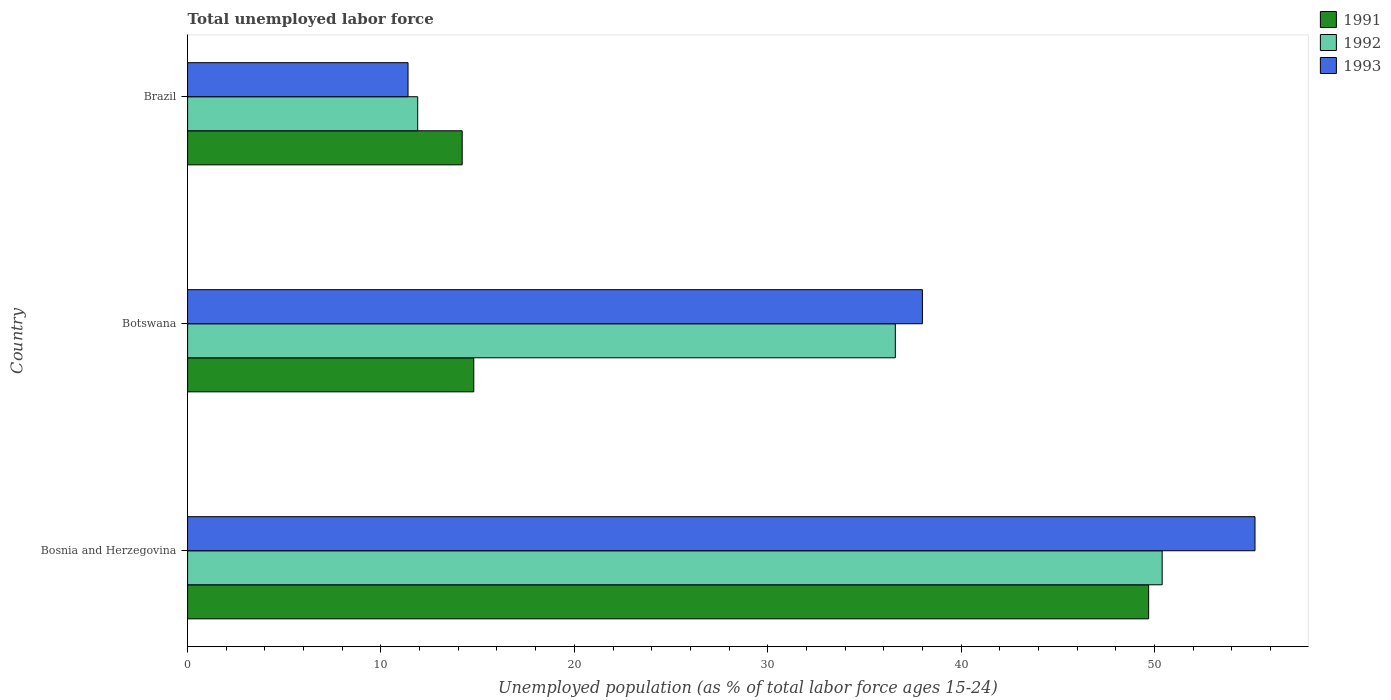How many different coloured bars are there?
Offer a very short reply. 3. How many groups of bars are there?
Keep it short and to the point. 3. Are the number of bars per tick equal to the number of legend labels?
Your answer should be compact. Yes. Are the number of bars on each tick of the Y-axis equal?
Make the answer very short. Yes. How many bars are there on the 1st tick from the top?
Provide a succinct answer. 3. How many bars are there on the 1st tick from the bottom?
Make the answer very short. 3. What is the label of the 3rd group of bars from the top?
Your answer should be compact. Bosnia and Herzegovina. What is the percentage of unemployed population in in 1991 in Brazil?
Your answer should be compact. 14.2. Across all countries, what is the maximum percentage of unemployed population in in 1993?
Offer a very short reply. 55.2. Across all countries, what is the minimum percentage of unemployed population in in 1992?
Make the answer very short. 11.9. In which country was the percentage of unemployed population in in 1992 maximum?
Give a very brief answer. Bosnia and Herzegovina. In which country was the percentage of unemployed population in in 1992 minimum?
Provide a short and direct response. Brazil. What is the total percentage of unemployed population in in 1991 in the graph?
Your response must be concise. 78.7. What is the difference between the percentage of unemployed population in in 1993 in Bosnia and Herzegovina and that in Brazil?
Your answer should be compact. 43.8. What is the difference between the percentage of unemployed population in in 1992 in Bosnia and Herzegovina and the percentage of unemployed population in in 1991 in Brazil?
Your answer should be compact. 36.2. What is the average percentage of unemployed population in in 1992 per country?
Keep it short and to the point. 32.97. What is the difference between the percentage of unemployed population in in 1992 and percentage of unemployed population in in 1991 in Brazil?
Your answer should be compact. -2.3. In how many countries, is the percentage of unemployed population in in 1993 greater than 28 %?
Make the answer very short. 2. What is the ratio of the percentage of unemployed population in in 1991 in Bosnia and Herzegovina to that in Brazil?
Keep it short and to the point. 3.5. Is the percentage of unemployed population in in 1993 in Bosnia and Herzegovina less than that in Brazil?
Provide a succinct answer. No. What is the difference between the highest and the second highest percentage of unemployed population in in 1992?
Provide a short and direct response. 13.8. What is the difference between the highest and the lowest percentage of unemployed population in in 1993?
Keep it short and to the point. 43.8. In how many countries, is the percentage of unemployed population in in 1991 greater than the average percentage of unemployed population in in 1991 taken over all countries?
Your answer should be compact. 1. Is the sum of the percentage of unemployed population in in 1992 in Botswana and Brazil greater than the maximum percentage of unemployed population in in 1991 across all countries?
Your response must be concise. No. What does the 3rd bar from the top in Brazil represents?
Give a very brief answer. 1991. Is it the case that in every country, the sum of the percentage of unemployed population in in 1992 and percentage of unemployed population in in 1991 is greater than the percentage of unemployed population in in 1993?
Ensure brevity in your answer.  Yes. Does the graph contain grids?
Offer a very short reply. No. How many legend labels are there?
Provide a short and direct response. 3. How are the legend labels stacked?
Provide a succinct answer. Vertical. What is the title of the graph?
Provide a short and direct response. Total unemployed labor force. Does "1967" appear as one of the legend labels in the graph?
Keep it short and to the point. No. What is the label or title of the X-axis?
Your answer should be very brief. Unemployed population (as % of total labor force ages 15-24). What is the Unemployed population (as % of total labor force ages 15-24) of 1991 in Bosnia and Herzegovina?
Your response must be concise. 49.7. What is the Unemployed population (as % of total labor force ages 15-24) in 1992 in Bosnia and Herzegovina?
Your response must be concise. 50.4. What is the Unemployed population (as % of total labor force ages 15-24) of 1993 in Bosnia and Herzegovina?
Provide a short and direct response. 55.2. What is the Unemployed population (as % of total labor force ages 15-24) in 1991 in Botswana?
Your response must be concise. 14.8. What is the Unemployed population (as % of total labor force ages 15-24) of 1992 in Botswana?
Your response must be concise. 36.6. What is the Unemployed population (as % of total labor force ages 15-24) of 1993 in Botswana?
Provide a succinct answer. 38. What is the Unemployed population (as % of total labor force ages 15-24) in 1991 in Brazil?
Offer a very short reply. 14.2. What is the Unemployed population (as % of total labor force ages 15-24) of 1992 in Brazil?
Your answer should be compact. 11.9. What is the Unemployed population (as % of total labor force ages 15-24) of 1993 in Brazil?
Provide a succinct answer. 11.4. Across all countries, what is the maximum Unemployed population (as % of total labor force ages 15-24) in 1991?
Provide a succinct answer. 49.7. Across all countries, what is the maximum Unemployed population (as % of total labor force ages 15-24) in 1992?
Offer a very short reply. 50.4. Across all countries, what is the maximum Unemployed population (as % of total labor force ages 15-24) of 1993?
Your answer should be compact. 55.2. Across all countries, what is the minimum Unemployed population (as % of total labor force ages 15-24) in 1991?
Provide a short and direct response. 14.2. Across all countries, what is the minimum Unemployed population (as % of total labor force ages 15-24) in 1992?
Provide a short and direct response. 11.9. Across all countries, what is the minimum Unemployed population (as % of total labor force ages 15-24) in 1993?
Ensure brevity in your answer.  11.4. What is the total Unemployed population (as % of total labor force ages 15-24) of 1991 in the graph?
Your answer should be very brief. 78.7. What is the total Unemployed population (as % of total labor force ages 15-24) of 1992 in the graph?
Offer a very short reply. 98.9. What is the total Unemployed population (as % of total labor force ages 15-24) in 1993 in the graph?
Offer a terse response. 104.6. What is the difference between the Unemployed population (as % of total labor force ages 15-24) of 1991 in Bosnia and Herzegovina and that in Botswana?
Your answer should be compact. 34.9. What is the difference between the Unemployed population (as % of total labor force ages 15-24) of 1992 in Bosnia and Herzegovina and that in Botswana?
Ensure brevity in your answer.  13.8. What is the difference between the Unemployed population (as % of total labor force ages 15-24) in 1993 in Bosnia and Herzegovina and that in Botswana?
Provide a succinct answer. 17.2. What is the difference between the Unemployed population (as % of total labor force ages 15-24) in 1991 in Bosnia and Herzegovina and that in Brazil?
Give a very brief answer. 35.5. What is the difference between the Unemployed population (as % of total labor force ages 15-24) of 1992 in Bosnia and Herzegovina and that in Brazil?
Ensure brevity in your answer.  38.5. What is the difference between the Unemployed population (as % of total labor force ages 15-24) of 1993 in Bosnia and Herzegovina and that in Brazil?
Your answer should be very brief. 43.8. What is the difference between the Unemployed population (as % of total labor force ages 15-24) in 1992 in Botswana and that in Brazil?
Keep it short and to the point. 24.7. What is the difference between the Unemployed population (as % of total labor force ages 15-24) of 1993 in Botswana and that in Brazil?
Provide a succinct answer. 26.6. What is the difference between the Unemployed population (as % of total labor force ages 15-24) of 1991 in Bosnia and Herzegovina and the Unemployed population (as % of total labor force ages 15-24) of 1992 in Botswana?
Ensure brevity in your answer.  13.1. What is the difference between the Unemployed population (as % of total labor force ages 15-24) in 1991 in Bosnia and Herzegovina and the Unemployed population (as % of total labor force ages 15-24) in 1993 in Botswana?
Offer a very short reply. 11.7. What is the difference between the Unemployed population (as % of total labor force ages 15-24) of 1991 in Bosnia and Herzegovina and the Unemployed population (as % of total labor force ages 15-24) of 1992 in Brazil?
Your answer should be very brief. 37.8. What is the difference between the Unemployed population (as % of total labor force ages 15-24) of 1991 in Bosnia and Herzegovina and the Unemployed population (as % of total labor force ages 15-24) of 1993 in Brazil?
Provide a short and direct response. 38.3. What is the difference between the Unemployed population (as % of total labor force ages 15-24) in 1991 in Botswana and the Unemployed population (as % of total labor force ages 15-24) in 1992 in Brazil?
Your response must be concise. 2.9. What is the difference between the Unemployed population (as % of total labor force ages 15-24) in 1991 in Botswana and the Unemployed population (as % of total labor force ages 15-24) in 1993 in Brazil?
Your response must be concise. 3.4. What is the difference between the Unemployed population (as % of total labor force ages 15-24) in 1992 in Botswana and the Unemployed population (as % of total labor force ages 15-24) in 1993 in Brazil?
Your answer should be compact. 25.2. What is the average Unemployed population (as % of total labor force ages 15-24) in 1991 per country?
Your response must be concise. 26.23. What is the average Unemployed population (as % of total labor force ages 15-24) of 1992 per country?
Offer a very short reply. 32.97. What is the average Unemployed population (as % of total labor force ages 15-24) of 1993 per country?
Ensure brevity in your answer.  34.87. What is the difference between the Unemployed population (as % of total labor force ages 15-24) in 1991 and Unemployed population (as % of total labor force ages 15-24) in 1992 in Bosnia and Herzegovina?
Your answer should be very brief. -0.7. What is the difference between the Unemployed population (as % of total labor force ages 15-24) of 1991 and Unemployed population (as % of total labor force ages 15-24) of 1993 in Bosnia and Herzegovina?
Offer a terse response. -5.5. What is the difference between the Unemployed population (as % of total labor force ages 15-24) in 1992 and Unemployed population (as % of total labor force ages 15-24) in 1993 in Bosnia and Herzegovina?
Give a very brief answer. -4.8. What is the difference between the Unemployed population (as % of total labor force ages 15-24) of 1991 and Unemployed population (as % of total labor force ages 15-24) of 1992 in Botswana?
Offer a terse response. -21.8. What is the difference between the Unemployed population (as % of total labor force ages 15-24) of 1991 and Unemployed population (as % of total labor force ages 15-24) of 1993 in Botswana?
Ensure brevity in your answer.  -23.2. What is the difference between the Unemployed population (as % of total labor force ages 15-24) of 1991 and Unemployed population (as % of total labor force ages 15-24) of 1992 in Brazil?
Your answer should be very brief. 2.3. What is the difference between the Unemployed population (as % of total labor force ages 15-24) of 1991 and Unemployed population (as % of total labor force ages 15-24) of 1993 in Brazil?
Your answer should be compact. 2.8. What is the difference between the Unemployed population (as % of total labor force ages 15-24) of 1992 and Unemployed population (as % of total labor force ages 15-24) of 1993 in Brazil?
Give a very brief answer. 0.5. What is the ratio of the Unemployed population (as % of total labor force ages 15-24) in 1991 in Bosnia and Herzegovina to that in Botswana?
Keep it short and to the point. 3.36. What is the ratio of the Unemployed population (as % of total labor force ages 15-24) of 1992 in Bosnia and Herzegovina to that in Botswana?
Keep it short and to the point. 1.38. What is the ratio of the Unemployed population (as % of total labor force ages 15-24) in 1993 in Bosnia and Herzegovina to that in Botswana?
Your response must be concise. 1.45. What is the ratio of the Unemployed population (as % of total labor force ages 15-24) of 1991 in Bosnia and Herzegovina to that in Brazil?
Keep it short and to the point. 3.5. What is the ratio of the Unemployed population (as % of total labor force ages 15-24) in 1992 in Bosnia and Herzegovina to that in Brazil?
Ensure brevity in your answer.  4.24. What is the ratio of the Unemployed population (as % of total labor force ages 15-24) of 1993 in Bosnia and Herzegovina to that in Brazil?
Offer a very short reply. 4.84. What is the ratio of the Unemployed population (as % of total labor force ages 15-24) in 1991 in Botswana to that in Brazil?
Provide a succinct answer. 1.04. What is the ratio of the Unemployed population (as % of total labor force ages 15-24) of 1992 in Botswana to that in Brazil?
Keep it short and to the point. 3.08. What is the difference between the highest and the second highest Unemployed population (as % of total labor force ages 15-24) of 1991?
Your answer should be very brief. 34.9. What is the difference between the highest and the second highest Unemployed population (as % of total labor force ages 15-24) in 1992?
Your answer should be compact. 13.8. What is the difference between the highest and the lowest Unemployed population (as % of total labor force ages 15-24) in 1991?
Give a very brief answer. 35.5. What is the difference between the highest and the lowest Unemployed population (as % of total labor force ages 15-24) in 1992?
Make the answer very short. 38.5. What is the difference between the highest and the lowest Unemployed population (as % of total labor force ages 15-24) of 1993?
Offer a terse response. 43.8. 